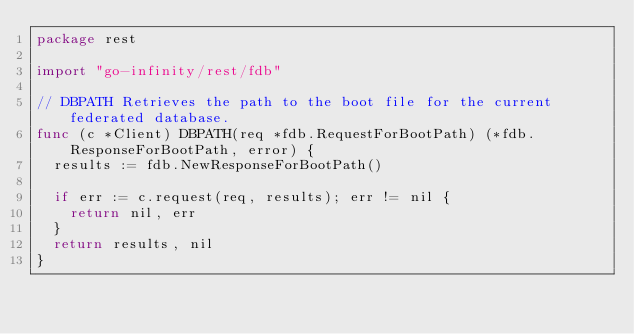Convert code to text. <code><loc_0><loc_0><loc_500><loc_500><_Go_>package rest

import "go-infinity/rest/fdb"

// DBPATH Retrieves the path to the boot file for the current federated database.
func (c *Client) DBPATH(req *fdb.RequestForBootPath) (*fdb.ResponseForBootPath, error) {
	results := fdb.NewResponseForBootPath()

	if err := c.request(req, results); err != nil {
		return nil, err
	}
	return results, nil
}
</code> 